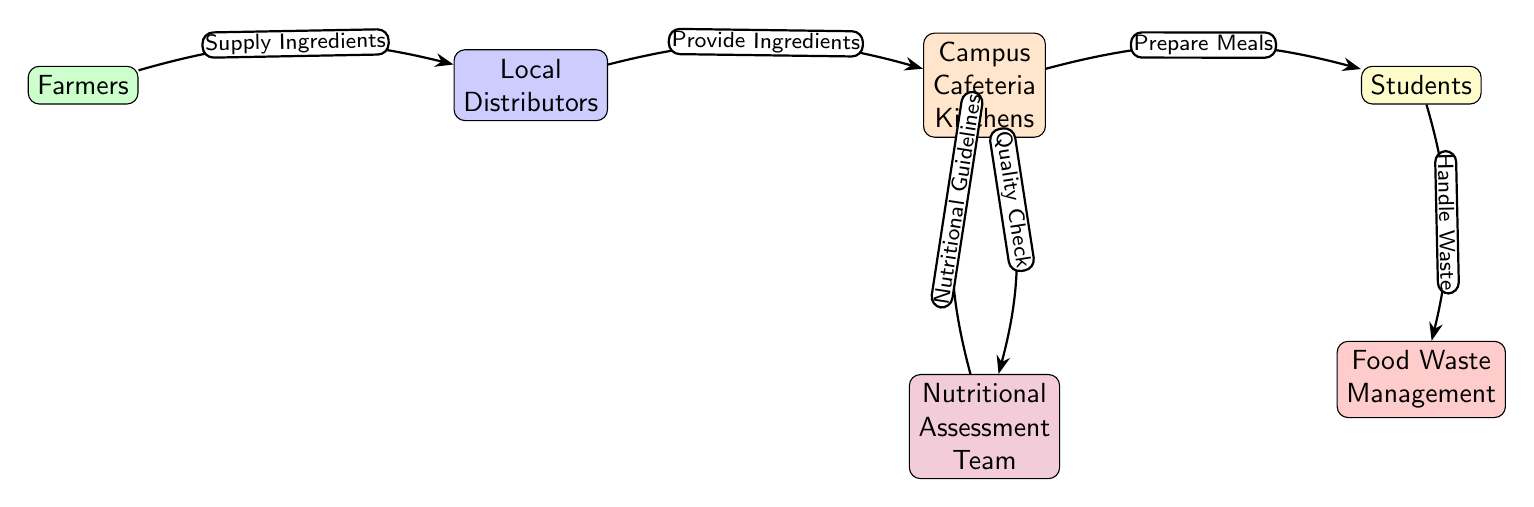What's the first node in the diagram? The first node in the diagram, on the left, is labeled "Farmers," which represents the starting point of the nutritional value chain.
Answer: Farmers How many nodes are in this diagram? By counting, the diagram consists of six nodes: Farmers, Local Distributors, Campus Cafeteria Kitchens, Nutritional Assessment Team, Students, and Food Waste Management.
Answer: 6 What is the role of Local Distributors in the diagram? Local Distributors supply ingredients to the Campus Cafeteria Kitchens, as indicated by the labeled edge connecting the two nodes.
Answer: Provide Ingredients Which node is responsible for handling food waste? The node responsible for handling food waste is "Food Waste Management," which is positioned below the Students node and connected by an edge indicating the handling of waste.
Answer: Food Waste Management What two nodes are directly connected to the Campus Cafeteria Kitchens? The two nodes directly connected to the Campus Cafeteria Kitchens are Local Distributors (providing ingredients) and Students (receiving prepared meals) as shown by the edges leading to and from this kitchen node.
Answer: Local Distributors and Students What do the Nutritional Assessment Team provide to the Campus Cafeteria Kitchens? The Nutritional Assessment Team provides nutritional guidelines, which they convey to the Campus Cafeteria Kitchens as indicated by the flow of the edges connecting these nodes.
Answer: Nutritional Guidelines What does the edge from Students to Food Waste Management represent? The edge from Students to Food Waste Management represents the process of handling waste generated from food consumption by students, indicating a system for managing food waste.
Answer: Handle Waste How does the Nutritional Assessment Team influence Campus Cafeteria Kitchens? The Nutritional Assessment Team influences Campus Cafeteria Kitchens by providing nutritional guidelines which affect the quality and preparation of the meals served therein.
Answer: Nutritional Guidelines What type of relationship is indicated between Farmers and Local Distributors? The relationship between Farmers and Local Distributors is a supply relationship where farmers supply ingredients to the distributors.
Answer: Supply Ingredients 